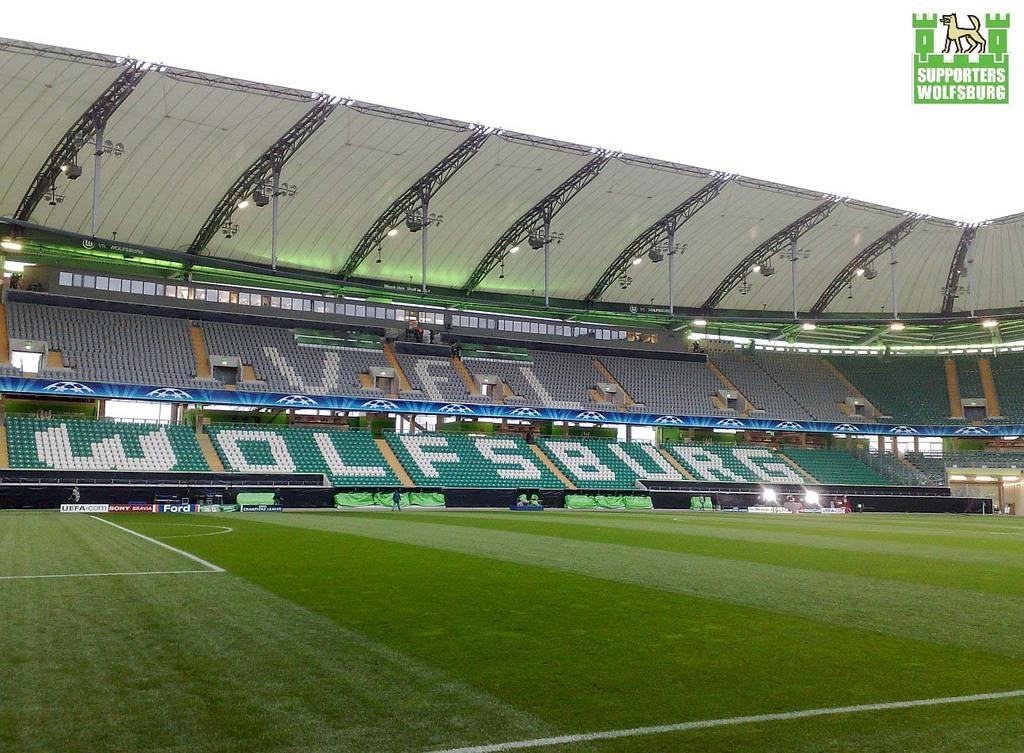Provide a one-sentence caption for the provided image. An empty soccer stadium reveals the word Wolfsburg printed on the seats. 